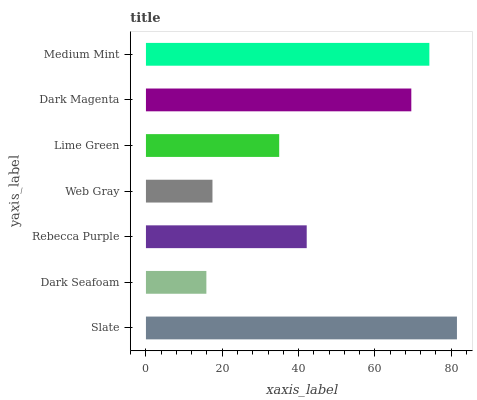Is Dark Seafoam the minimum?
Answer yes or no. Yes. Is Slate the maximum?
Answer yes or no. Yes. Is Rebecca Purple the minimum?
Answer yes or no. No. Is Rebecca Purple the maximum?
Answer yes or no. No. Is Rebecca Purple greater than Dark Seafoam?
Answer yes or no. Yes. Is Dark Seafoam less than Rebecca Purple?
Answer yes or no. Yes. Is Dark Seafoam greater than Rebecca Purple?
Answer yes or no. No. Is Rebecca Purple less than Dark Seafoam?
Answer yes or no. No. Is Rebecca Purple the high median?
Answer yes or no. Yes. Is Rebecca Purple the low median?
Answer yes or no. Yes. Is Web Gray the high median?
Answer yes or no. No. Is Dark Magenta the low median?
Answer yes or no. No. 